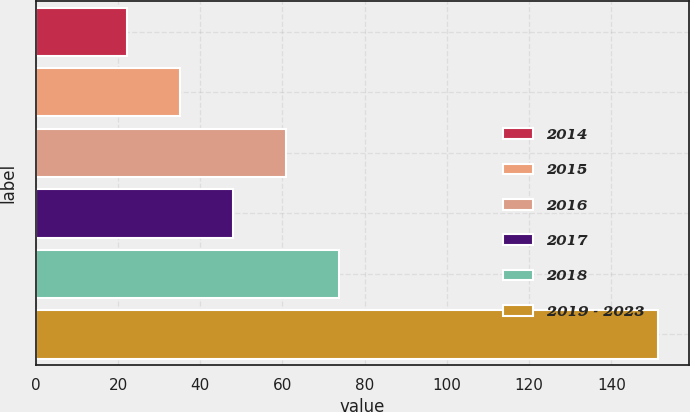Convert chart to OTSL. <chart><loc_0><loc_0><loc_500><loc_500><bar_chart><fcel>2014<fcel>2015<fcel>2016<fcel>2017<fcel>2018<fcel>2019 - 2023<nl><fcel>22.1<fcel>35.03<fcel>60.89<fcel>47.96<fcel>73.82<fcel>151.4<nl></chart> 